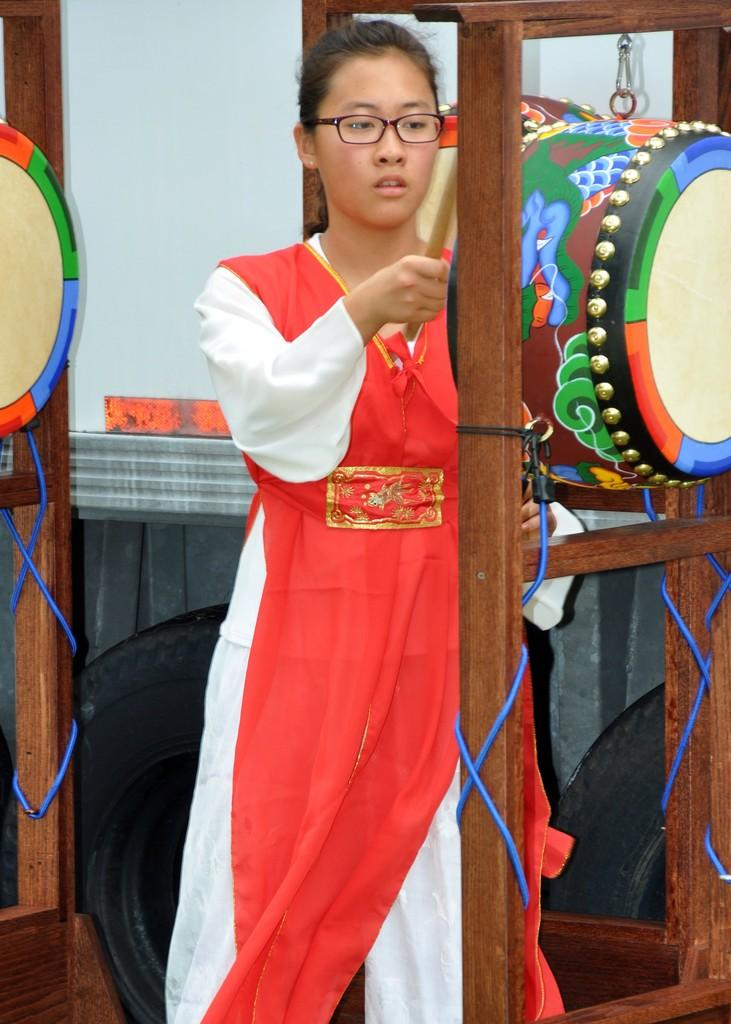Who is present in the image? There is a woman in the image. What is the woman wearing? The woman is wearing a red dress. What can be seen on the wooden stand in the image? There is a drum on the wooden stand. Are there any other drums visible in the image? Yes, there is another drum on the left side of the image. What type of cherries can be seen on the woman's dress in the image? There are no cherries present on the woman's dress in the image. 